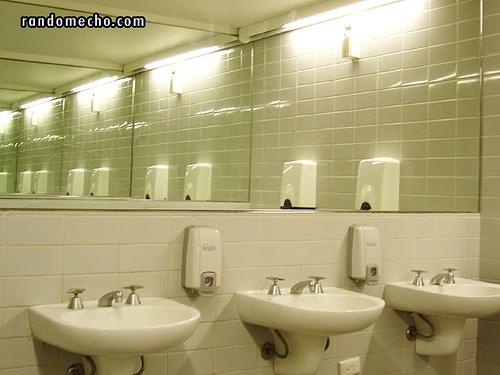How many sinks are there?

Choices:
A) six
B) three
C) four
D) five three 